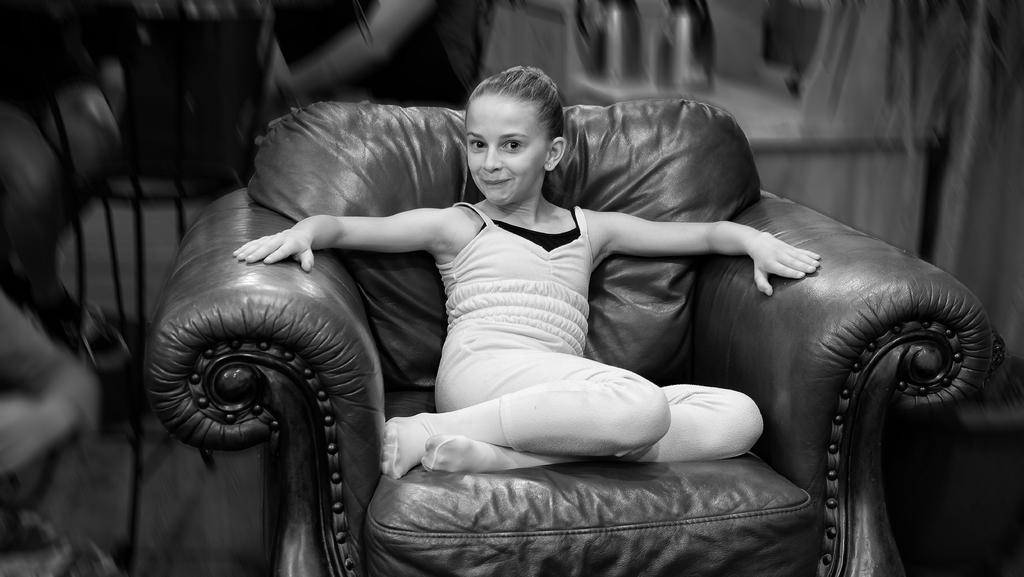What is the person in the image doing? The person is sitting on the couch in the image. What is the person wearing? The person is wearing a dress. Can you describe the background of the image? The background of the image is blurred. What is the color scheme of the image? The image is black and white. What type of wool is being used to create the hook in the image? There is no wool or hook present in the image. How does the person's cough affect the image? The person in the image is not coughing, and there is no indication that a cough would affect the image. 